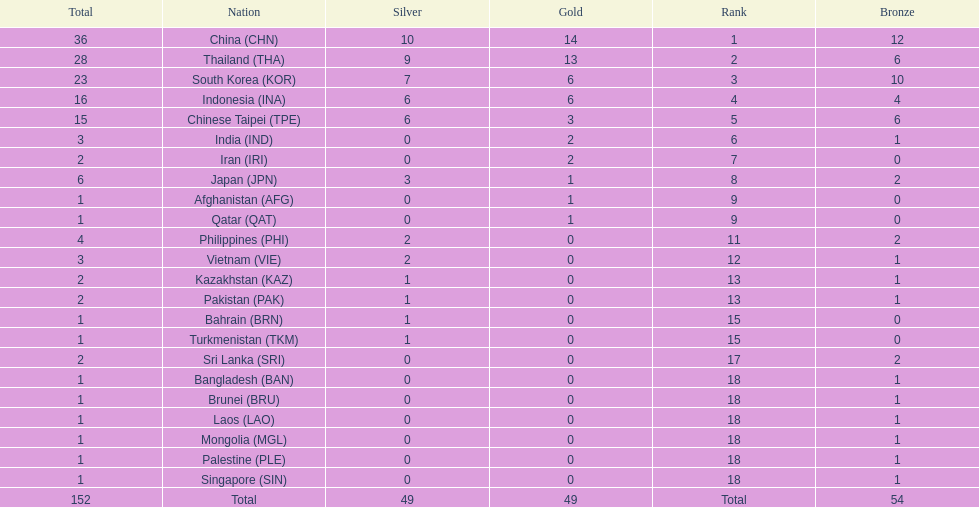How many nations received more than 5 gold medals? 4. 